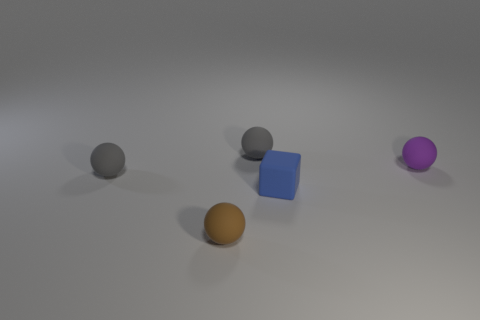Subtract all purple rubber spheres. How many spheres are left? 3 Subtract all brown spheres. How many spheres are left? 3 Add 2 small purple matte things. How many objects exist? 7 Subtract all blocks. How many objects are left? 4 Subtract all purple blocks. How many gray spheres are left? 2 Subtract 2 spheres. How many spheres are left? 2 Subtract all green cubes. Subtract all green cylinders. How many cubes are left? 1 Subtract all brown matte things. Subtract all tiny rubber cubes. How many objects are left? 3 Add 3 purple matte balls. How many purple matte balls are left? 4 Add 1 big green metallic objects. How many big green metallic objects exist? 1 